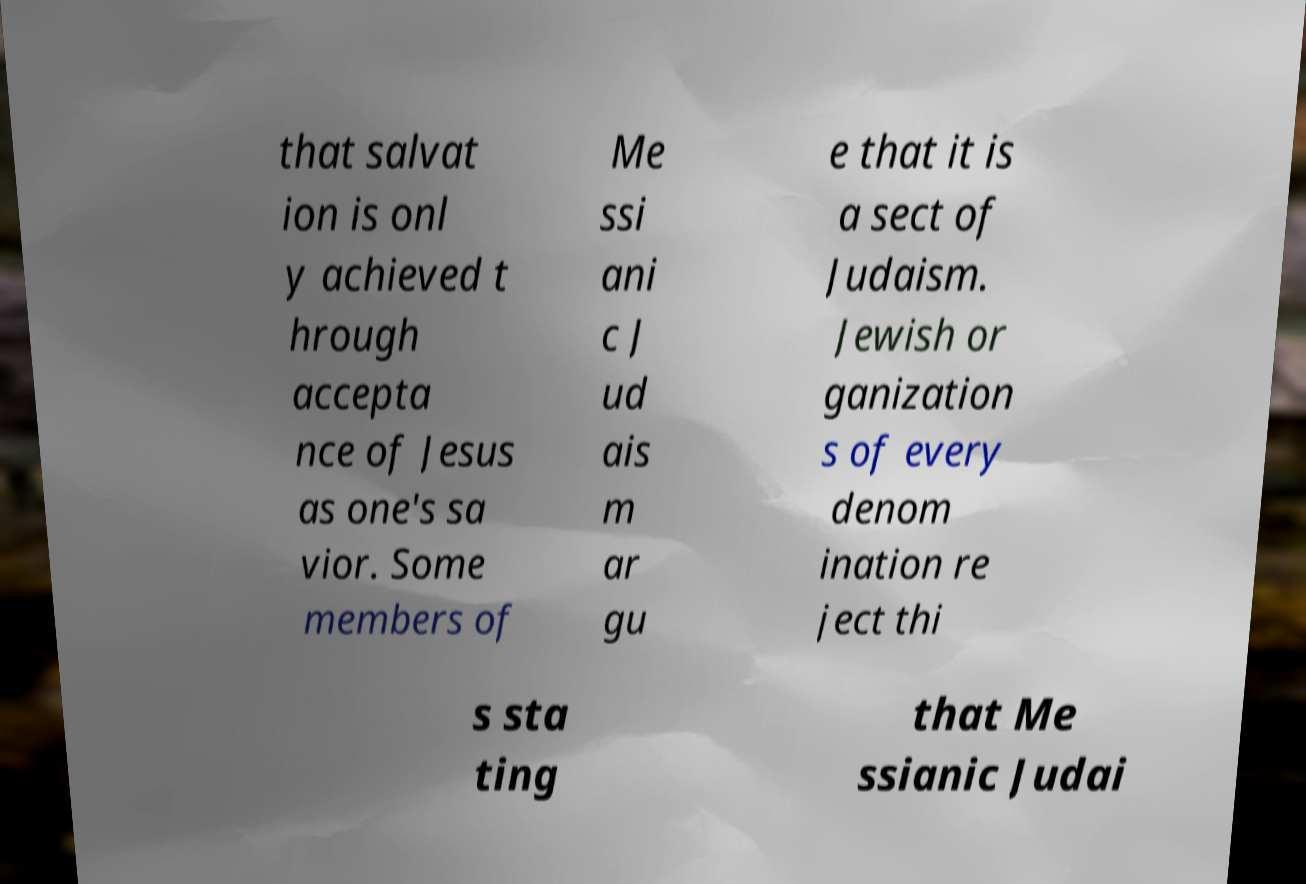I need the written content from this picture converted into text. Can you do that? that salvat ion is onl y achieved t hrough accepta nce of Jesus as one's sa vior. Some members of Me ssi ani c J ud ais m ar gu e that it is a sect of Judaism. Jewish or ganization s of every denom ination re ject thi s sta ting that Me ssianic Judai 